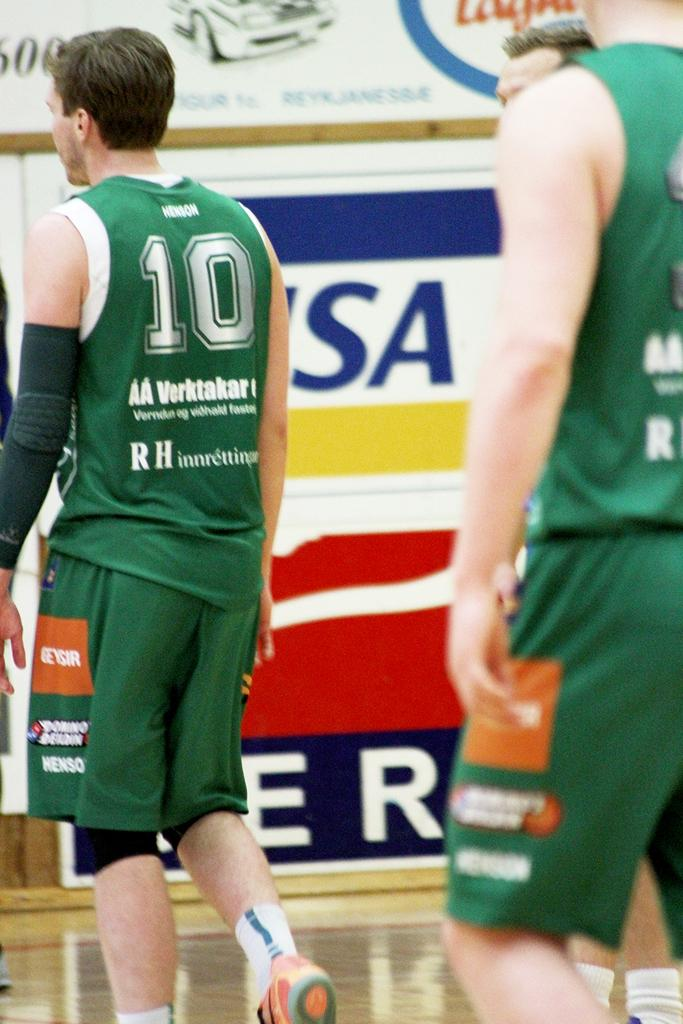<image>
Present a compact description of the photo's key features. Player wearing a green number 10 jersey walking on a basketball court. 